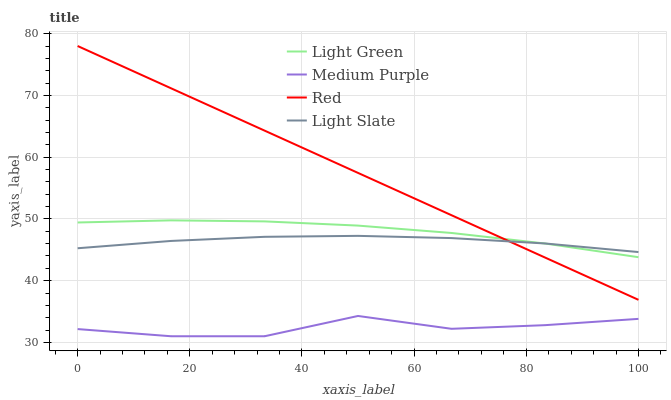Does Medium Purple have the minimum area under the curve?
Answer yes or no. Yes. Does Red have the maximum area under the curve?
Answer yes or no. Yes. Does Light Slate have the minimum area under the curve?
Answer yes or no. No. Does Light Slate have the maximum area under the curve?
Answer yes or no. No. Is Red the smoothest?
Answer yes or no. Yes. Is Medium Purple the roughest?
Answer yes or no. Yes. Is Light Slate the smoothest?
Answer yes or no. No. Is Light Slate the roughest?
Answer yes or no. No. Does Red have the lowest value?
Answer yes or no. No. Does Red have the highest value?
Answer yes or no. Yes. Does Light Slate have the highest value?
Answer yes or no. No. Is Medium Purple less than Red?
Answer yes or no. Yes. Is Light Slate greater than Medium Purple?
Answer yes or no. Yes. Does Medium Purple intersect Red?
Answer yes or no. No. 